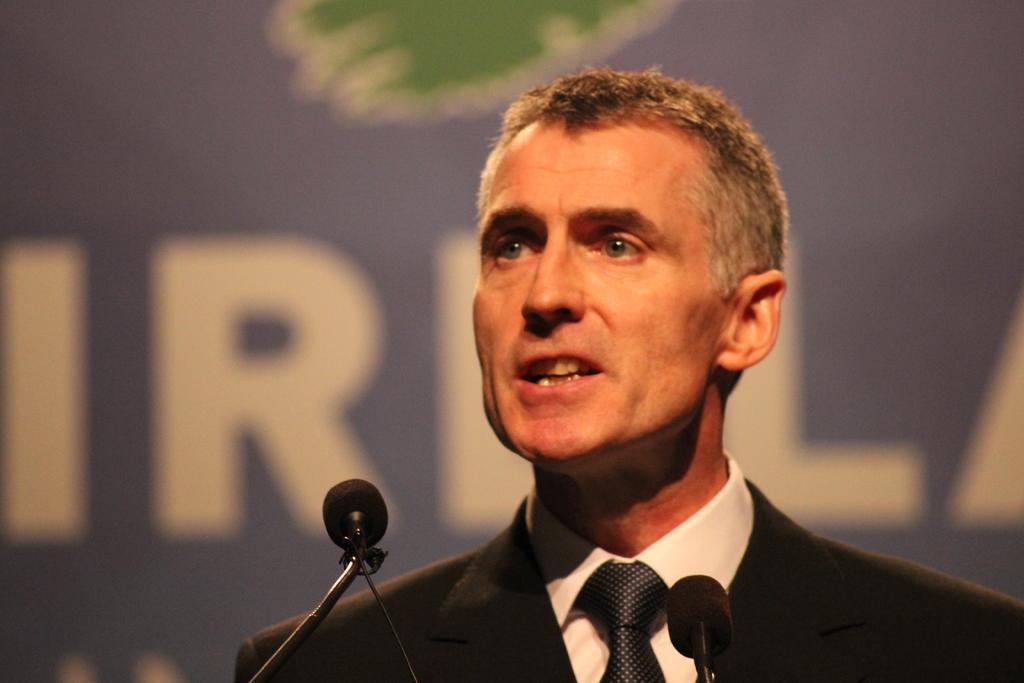Describe this image in one or two sentences. In the foreground of this picture we can see a person wearing suit and seems to be talking and we can see the microphones. In the background we can see the text on an object seems to be the banner. 